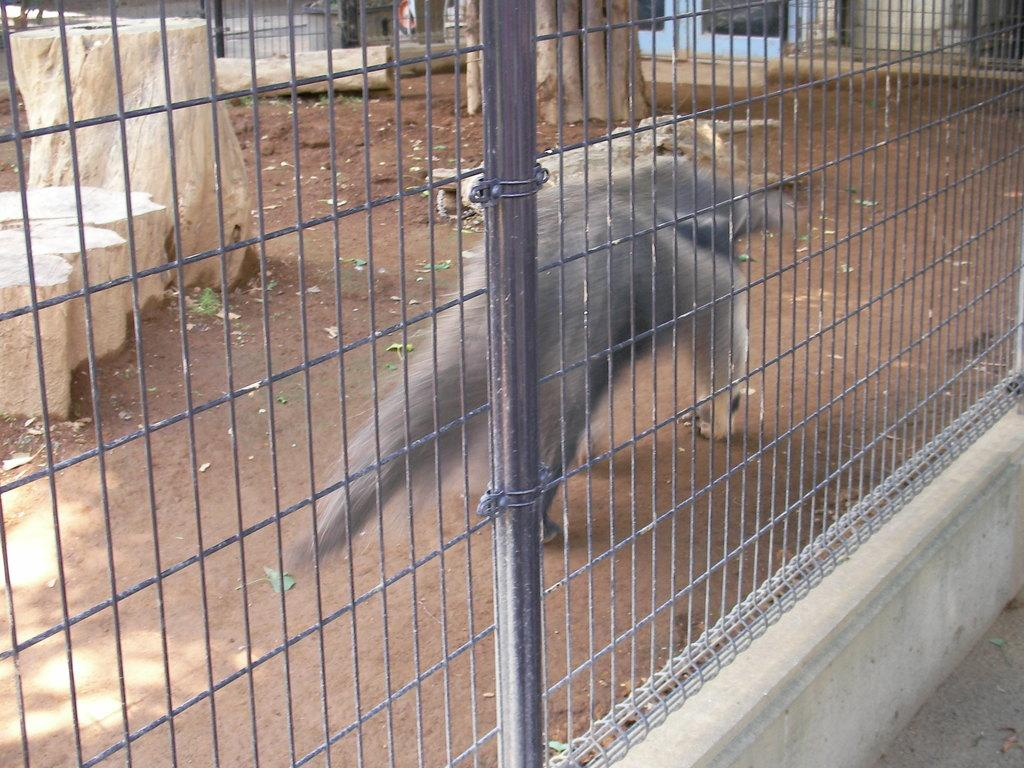What type of creature is present in the image? There is an animal in the image. Can you describe the animal's position in relation to the fence? The animal is standing beside a fence. What type of punishment is the animal receiving in the image? There is no indication of punishment in the image; the animal is simply standing beside a fence. 